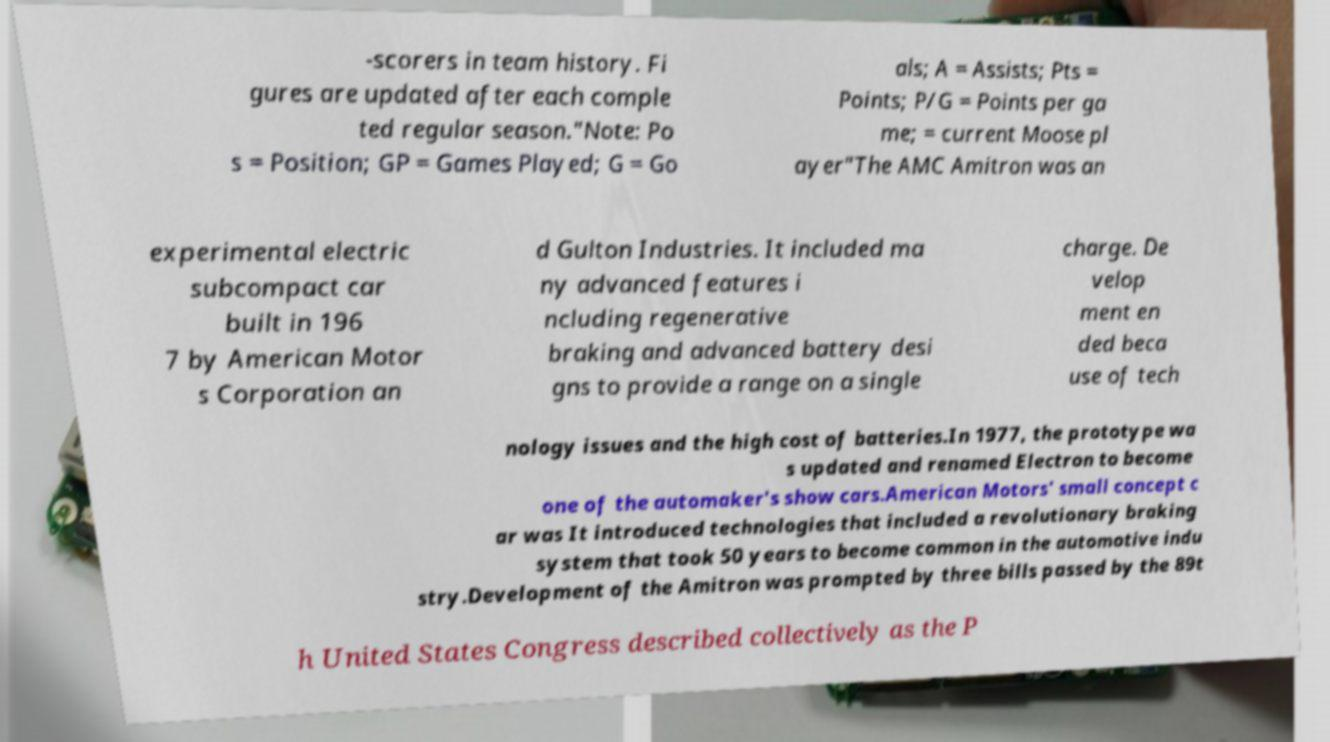For documentation purposes, I need the text within this image transcribed. Could you provide that? -scorers in team history. Fi gures are updated after each comple ted regular season."Note: Po s = Position; GP = Games Played; G = Go als; A = Assists; Pts = Points; P/G = Points per ga me; = current Moose pl ayer"The AMC Amitron was an experimental electric subcompact car built in 196 7 by American Motor s Corporation an d Gulton Industries. It included ma ny advanced features i ncluding regenerative braking and advanced battery desi gns to provide a range on a single charge. De velop ment en ded beca use of tech nology issues and the high cost of batteries.In 1977, the prototype wa s updated and renamed Electron to become one of the automaker's show cars.American Motors' small concept c ar was It introduced technologies that included a revolutionary braking system that took 50 years to become common in the automotive indu stry.Development of the Amitron was prompted by three bills passed by the 89t h United States Congress described collectively as the P 